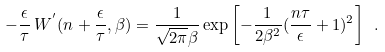<formula> <loc_0><loc_0><loc_500><loc_500>- \frac { \epsilon } { \tau } \, W ^ { ^ { \prime } } ( n + \frac { \epsilon } { \tau } , \beta ) = \frac { 1 } { \sqrt { 2 \pi } \beta } \exp \left [ - \frac { 1 } { 2 \beta ^ { 2 } } ( \frac { n \tau } { \epsilon } + 1 ) ^ { 2 } \right ] \ .</formula> 